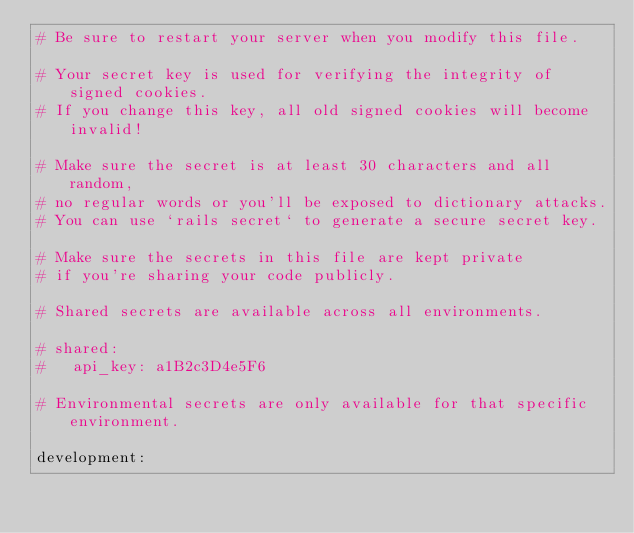<code> <loc_0><loc_0><loc_500><loc_500><_YAML_># Be sure to restart your server when you modify this file.

# Your secret key is used for verifying the integrity of signed cookies.
# If you change this key, all old signed cookies will become invalid!

# Make sure the secret is at least 30 characters and all random,
# no regular words or you'll be exposed to dictionary attacks.
# You can use `rails secret` to generate a secure secret key.

# Make sure the secrets in this file are kept private
# if you're sharing your code publicly.

# Shared secrets are available across all environments.

# shared:
#   api_key: a1B2c3D4e5F6

# Environmental secrets are only available for that specific environment.

development:</code> 